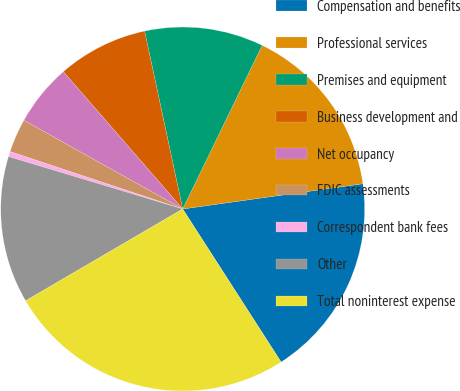<chart> <loc_0><loc_0><loc_500><loc_500><pie_chart><fcel>Compensation and benefits<fcel>Professional services<fcel>Premises and equipment<fcel>Business development and<fcel>Net occupancy<fcel>FDIC assessments<fcel>Correspondent bank fees<fcel>Other<fcel>Total noninterest expense<nl><fcel>18.12%<fcel>15.59%<fcel>10.55%<fcel>8.03%<fcel>5.51%<fcel>2.99%<fcel>0.46%<fcel>13.07%<fcel>25.68%<nl></chart> 